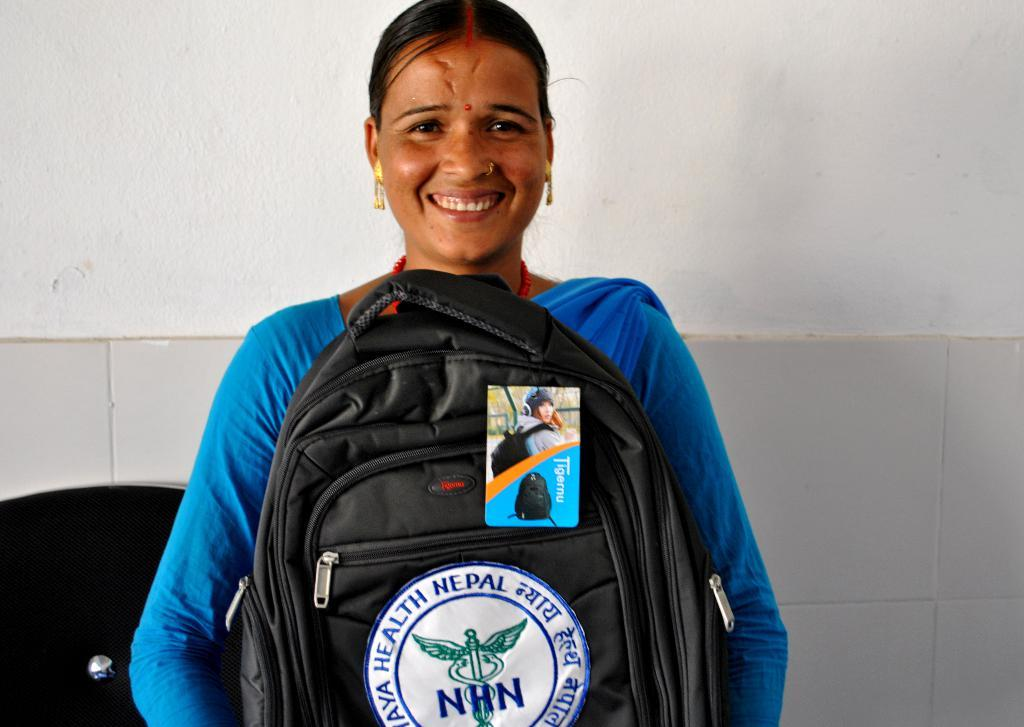<image>
Write a terse but informative summary of the picture. A smiling woman wears a backpack on her chest that says, "NHN". 